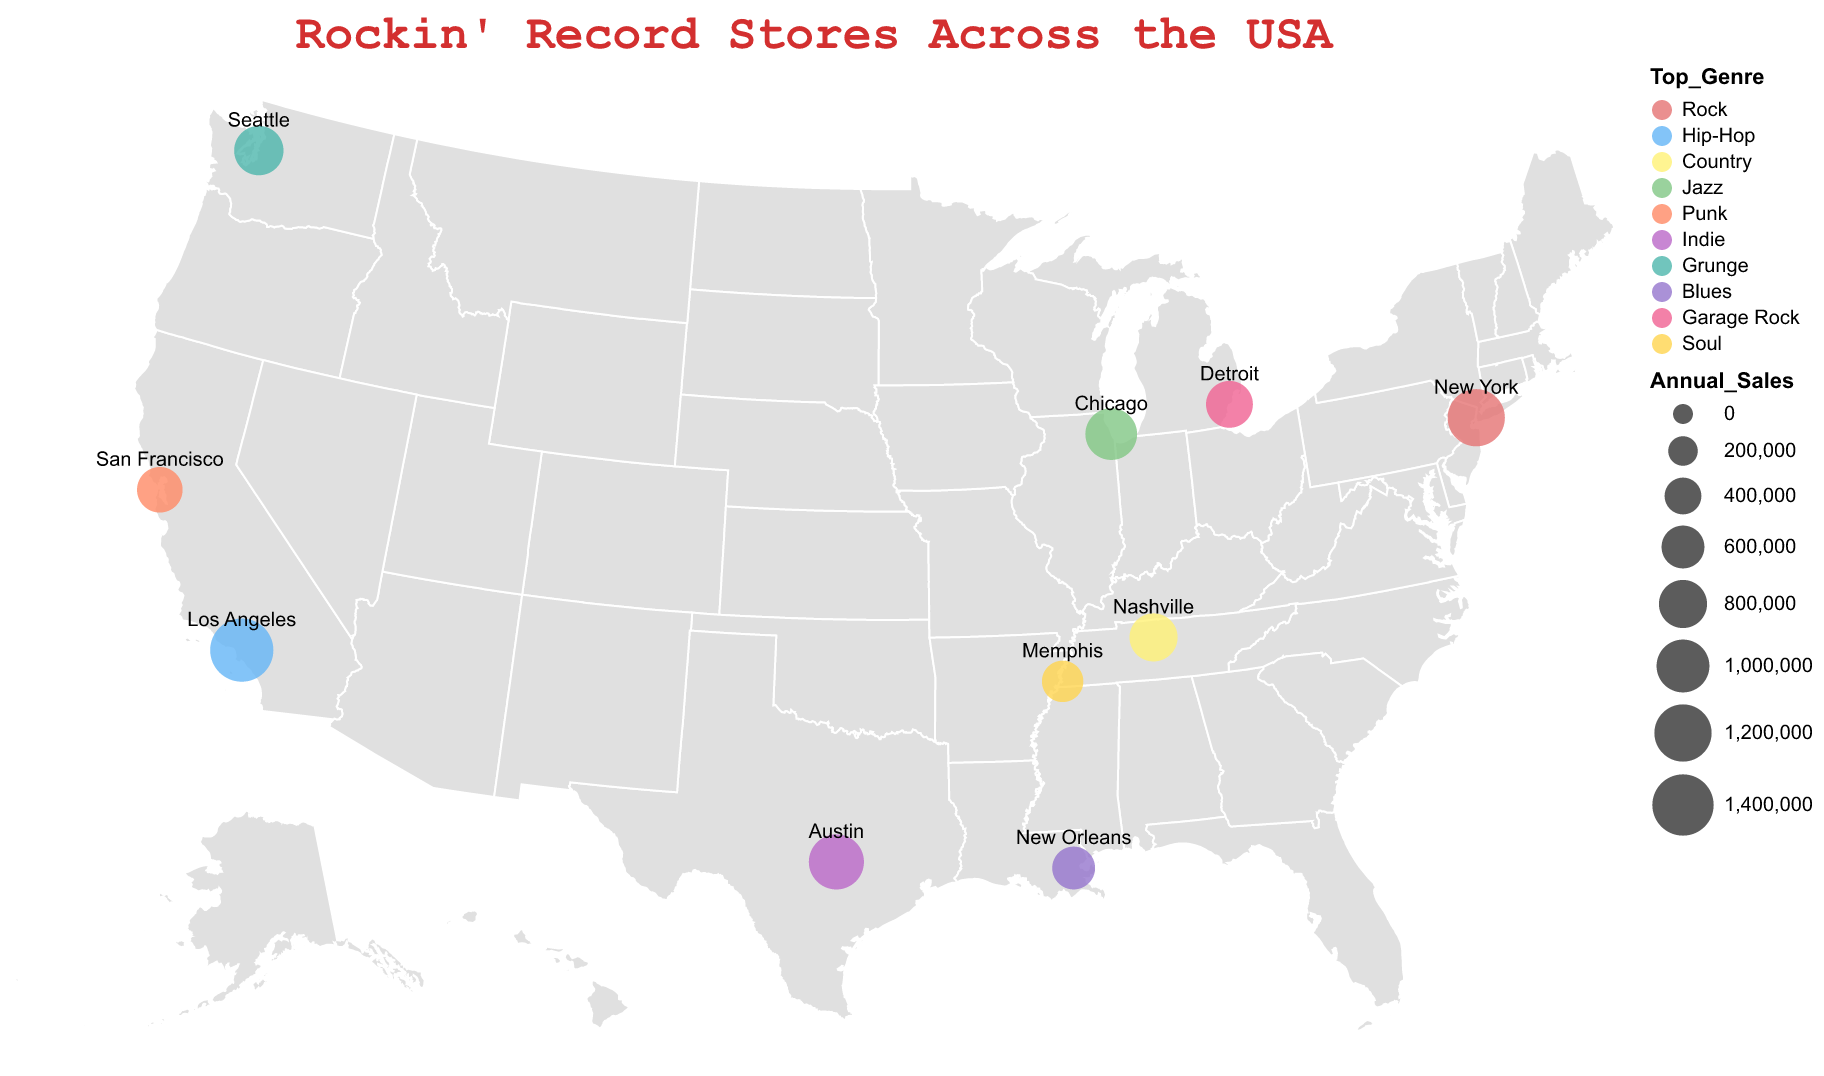What is the title of the figure? The title of the figure is placed at the top and in a larger font, it reads "Rockin' Record Stores Across the USA."
Answer: Rockin' Record Stores Across the USA Which city has the record store with the highest annual sales? The annual sales values are visually indicated by the size of the circles, and the largest circle represents the highest sales, which is in Los Angeles with Amoeba Music.
Answer: Los Angeles Which top genre is most popular among the record stores in the figure? Count the occurrences of each top genre mentioned in the tooltips or labels throughout the map; genres include Rock, Hip-Hop, Country, etc. The most popular genre is Rock.
Answer: Rock How do the annual sales of Rough Trade NYC compare to Amoeba Music? Rough Trade NYC in New York has an annual sales value represented by a circle of a specific size. Amoeba Music in Los Angeles has a larger circle. The tooltip confirms that Amoeba Music has $1,500,000 in sales compared to $1,200,000 for Rough Trade NYC.
Answer: Amoeba Music has higher sales Which city is represented by a circle with a medium size and is associated with the genre "Indie"? Locate the medium-sized circle that is colored to represent the genre "Indie" and check the corresponding city on the tooltip or label. This circle is found in Austin for Waterloo Records.
Answer: Austin Which store has the lowest annual sales, and what genre does it specialize in? Identify the smallest circle on the map, which represents the lowest annual sales. The smallest circle is in Memphis for Goner Records and the genre is "Soul."
Answer: Goner Records, Soul Calculate the average annual sales of all the record stores shown on the map. Add up the annual sales values for all stores: 1,200,000 (Rough Trade NYC) + 1,500,000 (Amoeba Music) + 800,000 (Grimey's New & Preloved Music) + 950,000 (Reckless Records) + 700,000 (1-2-3-4 Go! Records) + 1,100,000 (Waterloo Records) + 850,000 (Easy Street Records) + 600,000 (Louisiana Music Factory) + 750,000 (Third Man Records) + 550,000 (Goner Records). Total is 8,000,000. Divide by the number of stores (10): 8,000,000 / 10 = 800,000
Answer: 800,000 What is the common genre for stores with annual sales above $1,000,000? Check the top genres for stores with annual sales over $1,000,000. Rough Trade NYC (Rock), Amoeba Music (Hip-Hop), and Waterloo Records (Indie) all have sales over $1,000,000. There is no single common genre among them.
Answer: No common genre Which city in the figure is associated with the genre "Blues" and what are its annual sales? Locate the city associated with the "Blues" genre by checking the color coding on the map and checking the tooltip or label for "Blues." The city is New Orleans and the store is Louisiana Music Factory with annual sales of $600,000.
Answer: New Orleans, $600,000 What is the difference in annual sales between the record stores in Chicago and Detroit? The annual sales of Reckless Records in Chicago is $950,000, and Third Man Records in Detroit is $750,000. The difference is $950,000 - $750,000 = $200,000.
Answer: $200,000 